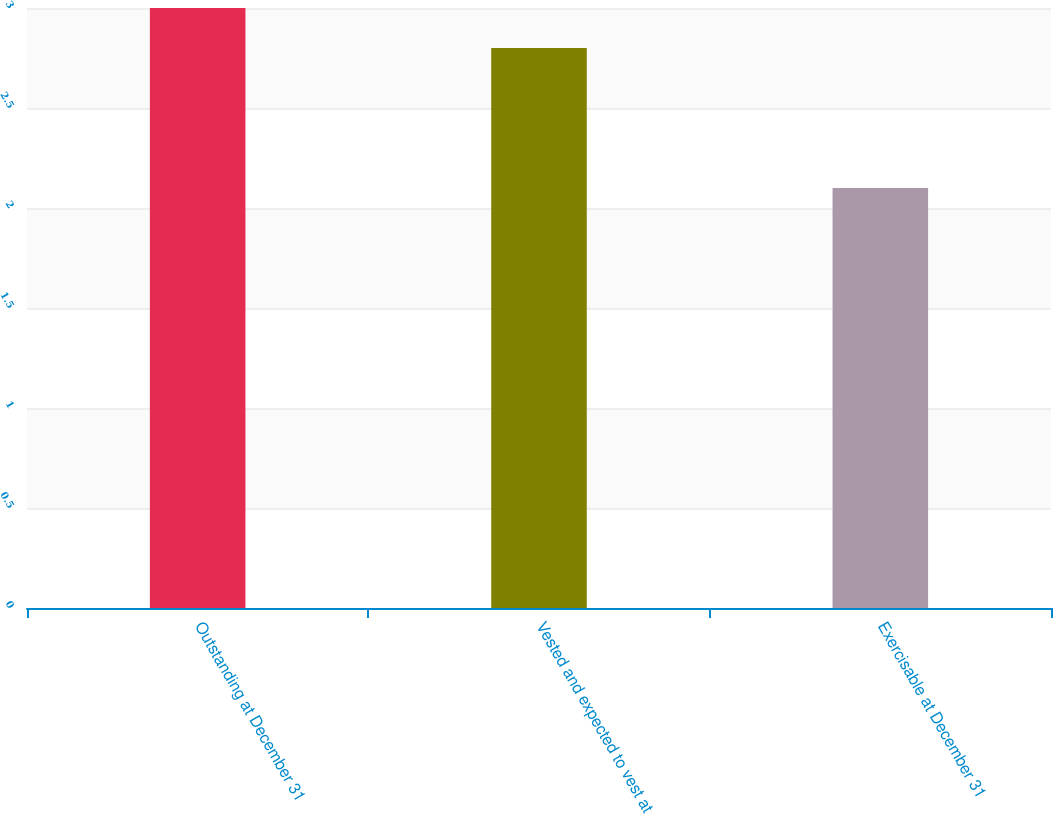<chart> <loc_0><loc_0><loc_500><loc_500><bar_chart><fcel>Outstanding at December 31<fcel>Vested and expected to vest at<fcel>Exercisable at December 31<nl><fcel>3<fcel>2.8<fcel>2.1<nl></chart> 